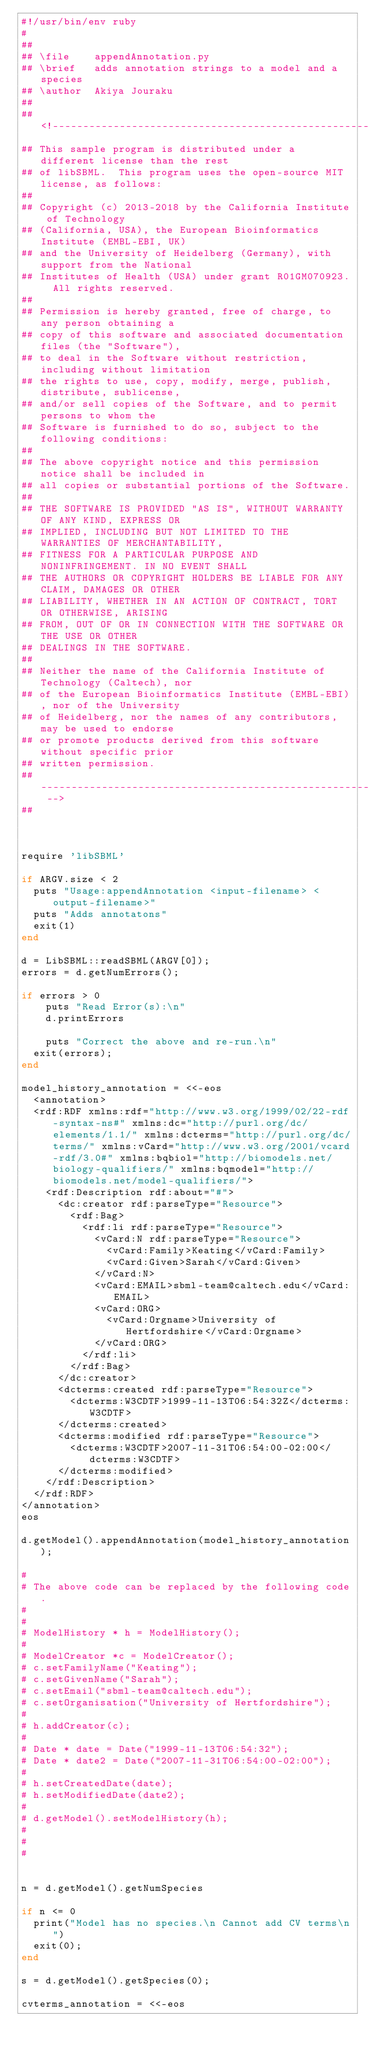<code> <loc_0><loc_0><loc_500><loc_500><_Ruby_>#!/usr/bin/env ruby
#
## 
## \file    appendAnnotation.py
## \brief   adds annotation strings to a model and a species
## \author  Akiya Jouraku
## 
## <!--------------------------------------------------------------------------
## This sample program is distributed under a different license than the rest
## of libSBML.  This program uses the open-source MIT license, as follows:
##
## Copyright (c) 2013-2018 by the California Institute of Technology
## (California, USA), the European Bioinformatics Institute (EMBL-EBI, UK)
## and the University of Heidelberg (Germany), with support from the National
## Institutes of Health (USA) under grant R01GM070923.  All rights reserved.
##
## Permission is hereby granted, free of charge, to any person obtaining a
## copy of this software and associated documentation files (the "Software"),
## to deal in the Software without restriction, including without limitation
## the rights to use, copy, modify, merge, publish, distribute, sublicense,
## and/or sell copies of the Software, and to permit persons to whom the
## Software is furnished to do so, subject to the following conditions:
##
## The above copyright notice and this permission notice shall be included in
## all copies or substantial portions of the Software.
##
## THE SOFTWARE IS PROVIDED "AS IS", WITHOUT WARRANTY OF ANY KIND, EXPRESS OR
## IMPLIED, INCLUDING BUT NOT LIMITED TO THE WARRANTIES OF MERCHANTABILITY,
## FITNESS FOR A PARTICULAR PURPOSE AND NONINFRINGEMENT. IN NO EVENT SHALL
## THE AUTHORS OR COPYRIGHT HOLDERS BE LIABLE FOR ANY CLAIM, DAMAGES OR OTHER
## LIABILITY, WHETHER IN AN ACTION OF CONTRACT, TORT OR OTHERWISE, ARISING
## FROM, OUT OF OR IN CONNECTION WITH THE SOFTWARE OR THE USE OR OTHER
## DEALINGS IN THE SOFTWARE.
##
## Neither the name of the California Institute of Technology (Caltech), nor
## of the European Bioinformatics Institute (EMBL-EBI), nor of the University
## of Heidelberg, nor the names of any contributors, may be used to endorse
## or promote products derived from this software without specific prior
## written permission.
## ------------------------------------------------------------------------ -->
## 



require 'libSBML'

if ARGV.size < 2
  puts "Usage:appendAnnotation <input-filename> <output-filename>"
  puts "Adds annotatons"  
  exit(1)
end

d = LibSBML::readSBML(ARGV[0]);
errors = d.getNumErrors();

if errors > 0
    puts "Read Error(s):\n"
    d.printErrors

    puts "Correct the above and re-run.\n"
	exit(errors);
end

model_history_annotation = <<-eos
  <annotation>
  <rdf:RDF xmlns:rdf="http://www.w3.org/1999/02/22-rdf-syntax-ns#" xmlns:dc="http://purl.org/dc/elements/1.1/" xmlns:dcterms="http://purl.org/dc/terms/" xmlns:vCard="http://www.w3.org/2001/vcard-rdf/3.0#" xmlns:bqbiol="http://biomodels.net/biology-qualifiers/" xmlns:bqmodel="http://biomodels.net/model-qualifiers/">
    <rdf:Description rdf:about="#">
      <dc:creator rdf:parseType="Resource">
        <rdf:Bag>
          <rdf:li rdf:parseType="Resource">
            <vCard:N rdf:parseType="Resource">
              <vCard:Family>Keating</vCard:Family>
              <vCard:Given>Sarah</vCard:Given>
            </vCard:N>
            <vCard:EMAIL>sbml-team@caltech.edu</vCard:EMAIL>
            <vCard:ORG>
              <vCard:Orgname>University of Hertfordshire</vCard:Orgname>
            </vCard:ORG>
          </rdf:li>
        </rdf:Bag>
      </dc:creator>
      <dcterms:created rdf:parseType="Resource">
        <dcterms:W3CDTF>1999-11-13T06:54:32Z</dcterms:W3CDTF>
      </dcterms:created>
      <dcterms:modified rdf:parseType="Resource">
        <dcterms:W3CDTF>2007-11-31T06:54:00-02:00</dcterms:W3CDTF>
      </dcterms:modified>
    </rdf:Description>
  </rdf:RDF>
</annotation>
eos

d.getModel().appendAnnotation(model_history_annotation);

# 
# The above code can be replaced by the following code.
# 
# 
# ModelHistory * h = ModelHistory();
# 
# ModelCreator *c = ModelCreator();
# c.setFamilyName("Keating");
# c.setGivenName("Sarah");
# c.setEmail("sbml-team@caltech.edu");
# c.setOrganisation("University of Hertfordshire");
# 
# h.addCreator(c);
# 
# Date * date = Date("1999-11-13T06:54:32");
# Date * date2 = Date("2007-11-31T06:54:00-02:00");
# 
# h.setCreatedDate(date);
# h.setModifiedDate(date2);
# 
# d.getModel().setModelHistory(h);
# 
# 
# 


n = d.getModel().getNumSpecies

if n <= 0
  print("Model has no species.\n Cannot add CV terms\n")
  exit(0);
end

s = d.getModel().getSpecies(0);

cvterms_annotation = <<-eos</code> 